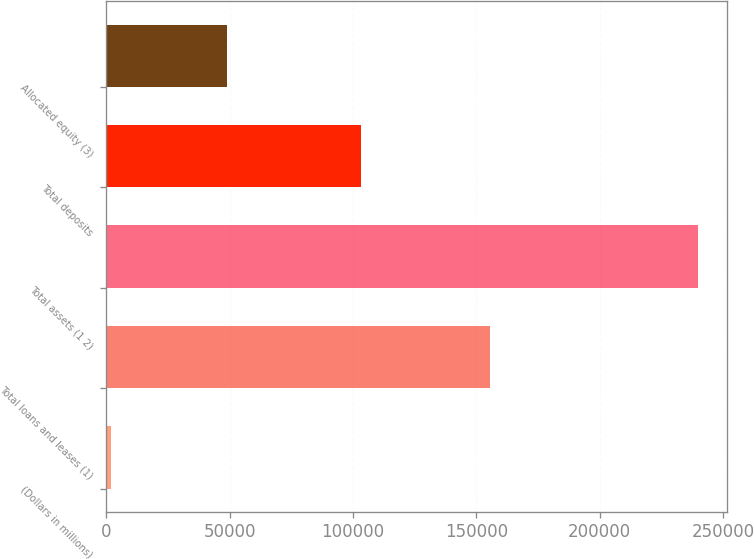Convert chart. <chart><loc_0><loc_0><loc_500><loc_500><bar_chart><fcel>(Dollars in millions)<fcel>Total loans and leases (1)<fcel>Total assets (1 2)<fcel>Total deposits<fcel>Allocated equity (3)<nl><fcel>2009<fcel>155561<fcel>239642<fcel>103122<fcel>49015<nl></chart> 